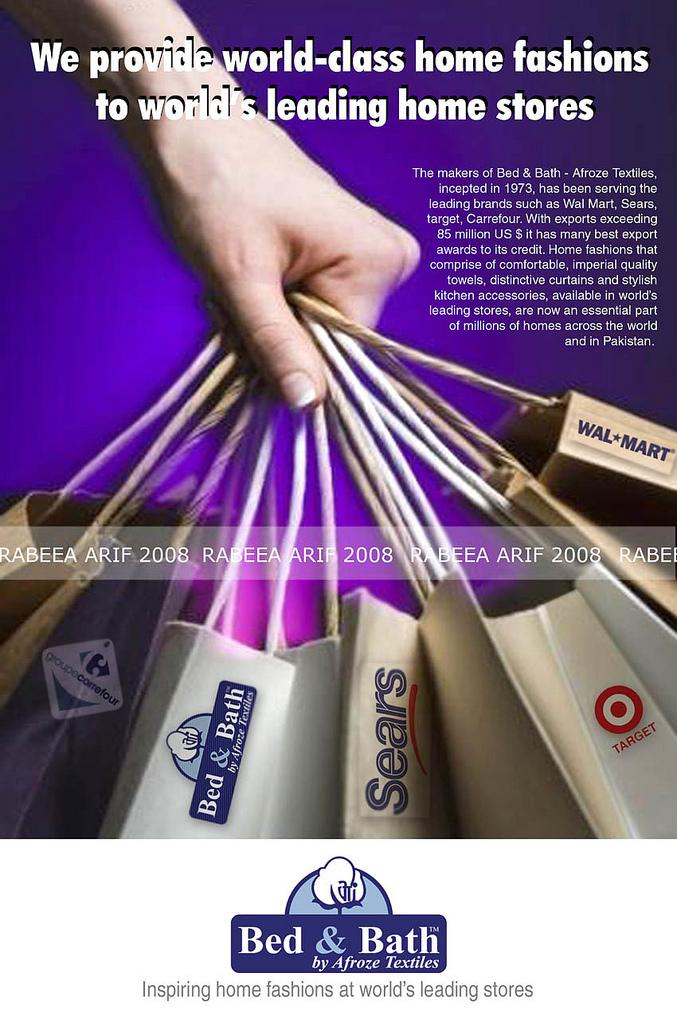What is the main subject of the poster in the image? The poster depicts a person's hand holding carry bags. What else can be seen on the poster besides the hand and carry bags? There is text written on the poster. How many geese are flying in the distance in the image? There are no geese or any indication of distance in the image; it only features a poster with a hand holding carry bags and text. 